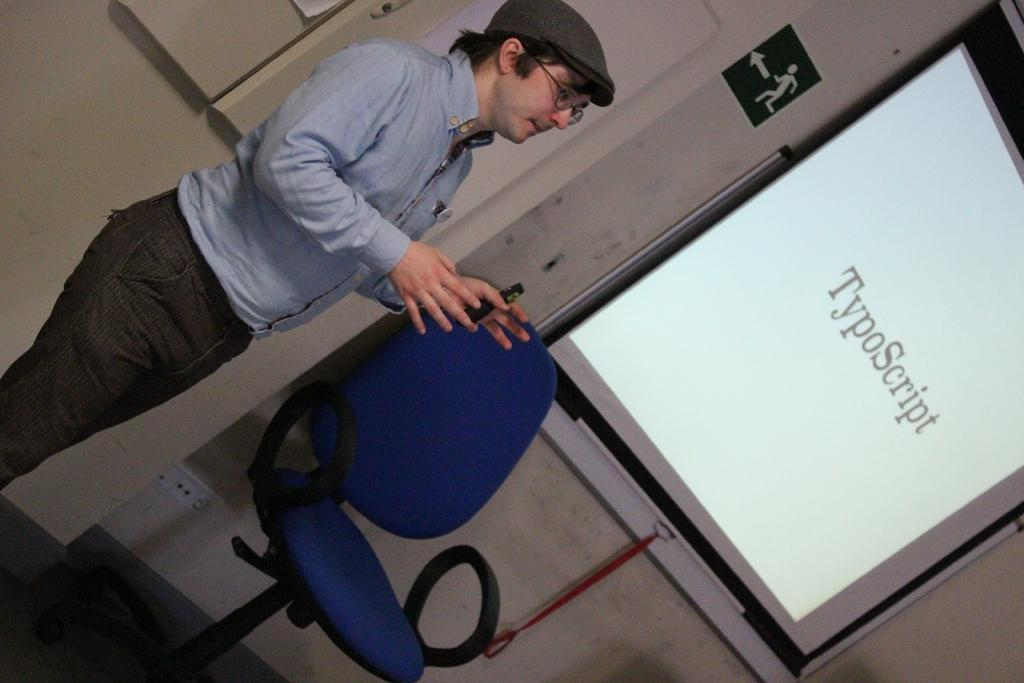What is the man in the image doing? The man is standing in the image. What is the man holding in the image? The man is holding an object. What piece of furniture is beside the man? There is a chair beside the man. What can be seen on the wall in the image? There is a screen and a sign board on the wall. What type of lock can be seen on the field in the image? There is no field or lock present in the image. 